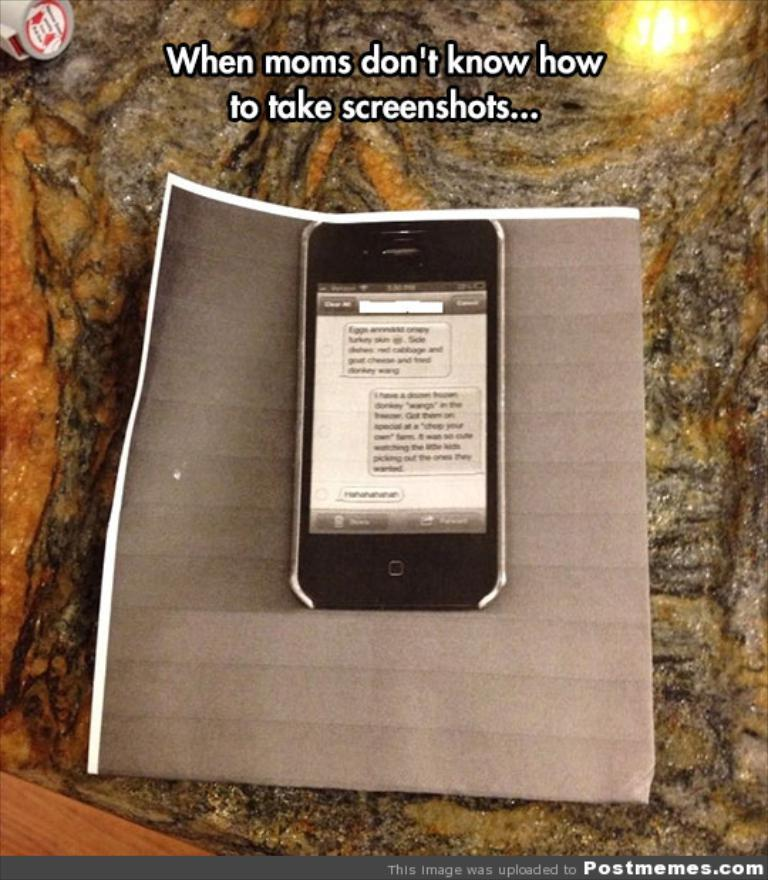What electronic device is visible in the image? There is a mobile phone in the image. Where is the mobile phone located? The mobile phone is on a surface. What is between the mobile phone and the surface? There is a paper between the mobile phone and the surface. Can you describe any text visible in the image? Yes, there are words written at the top of the image. How does the creator of the mobile phone push the device in the image? There is no person or creator depicted in the image, and the mobile phone is not being pushed. 